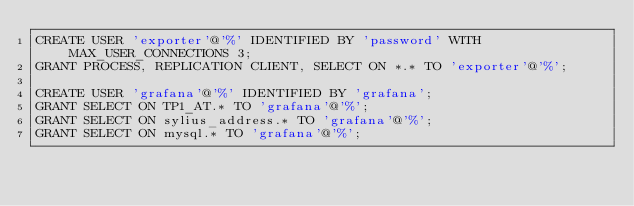<code> <loc_0><loc_0><loc_500><loc_500><_SQL_>CREATE USER 'exporter'@'%' IDENTIFIED BY 'password' WITH MAX_USER_CONNECTIONS 3;
GRANT PROCESS, REPLICATION CLIENT, SELECT ON *.* TO 'exporter'@'%';

CREATE USER 'grafana'@'%' IDENTIFIED BY 'grafana';
GRANT SELECT ON TP1_AT.* TO 'grafana'@'%';
GRANT SELECT ON sylius_address.* TO 'grafana'@'%';
GRANT SELECT ON mysql.* TO 'grafana'@'%';</code> 